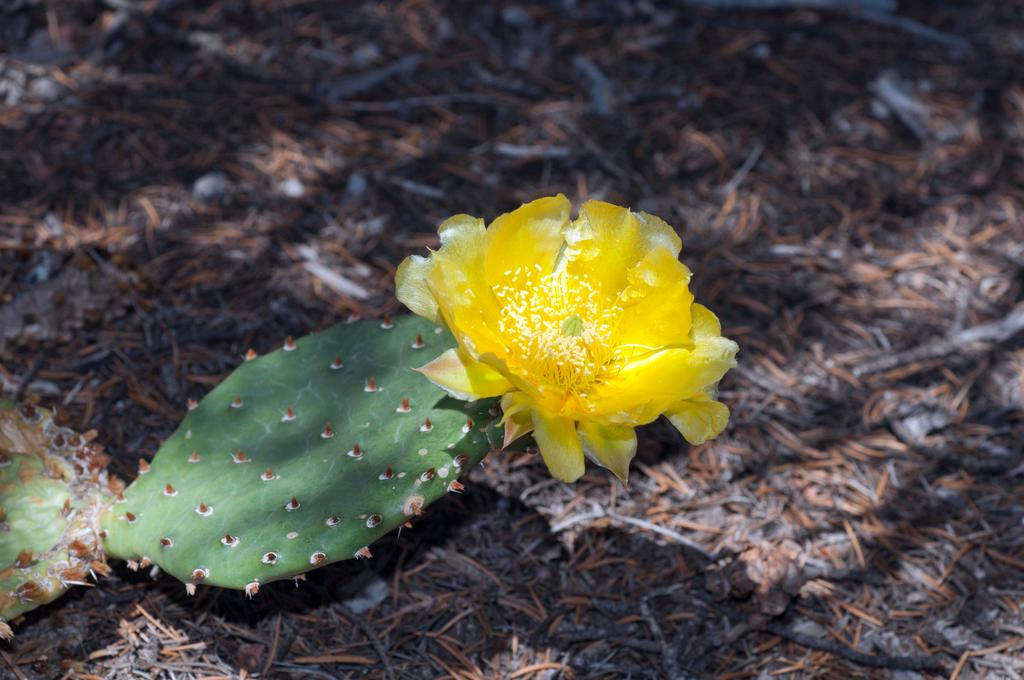What type of vegetation can be seen in the image? There are dry leaves and a cactus plant in the image. What other type of plant is present in the image? There is a flower in the image. Can you describe the top part of the image? The top part of the image is blurred. What type of apparatus is being used to fulfill the desire of the cactus plant in the image? There is no apparatus or desire present in the image; it only features dry leaves, a cactus plant, and a flower. 